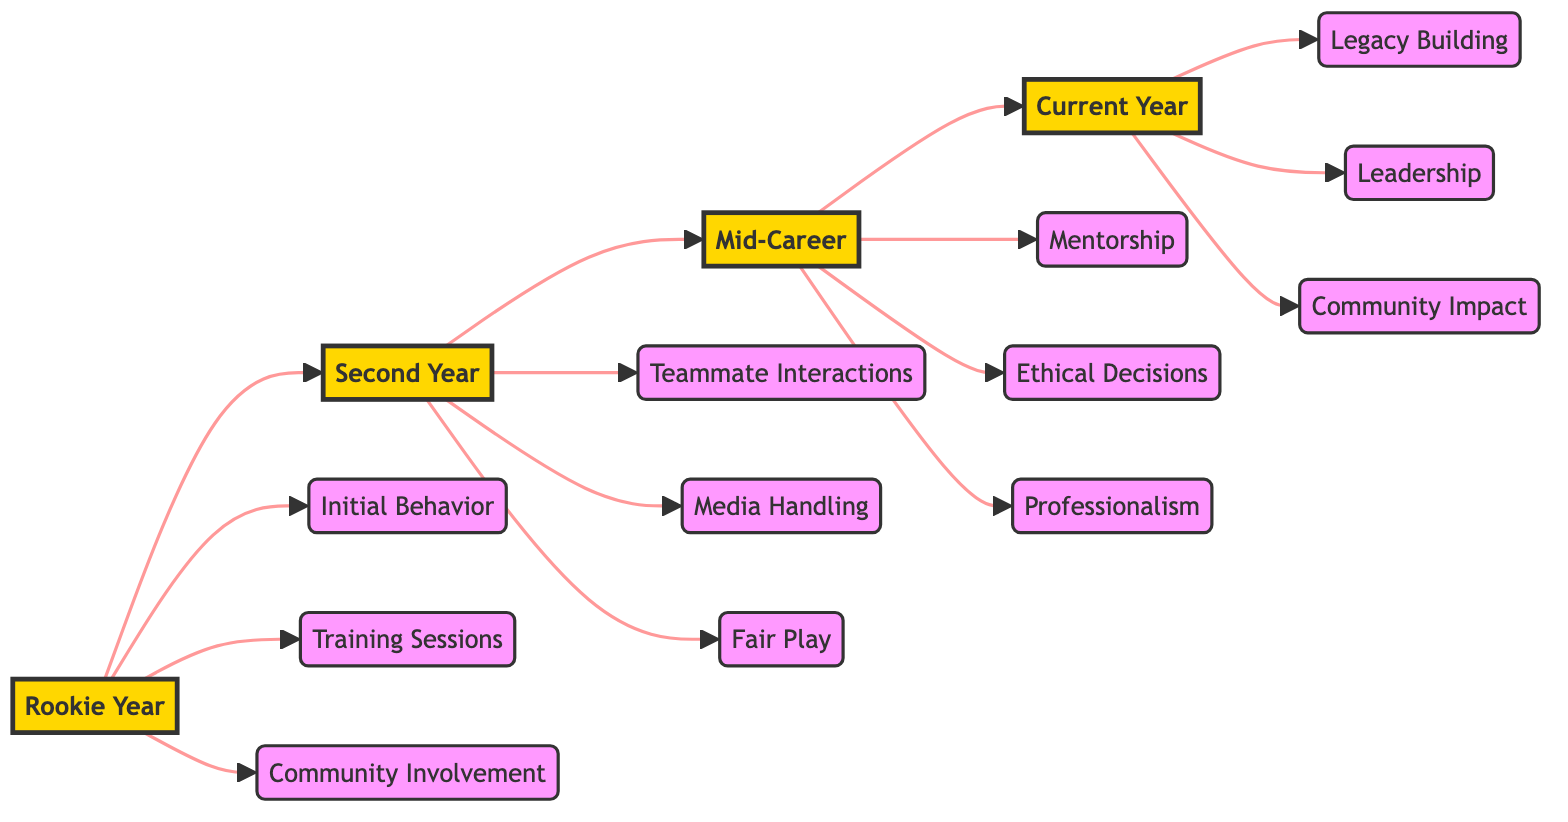What are the three aspects focused on in the Rookie Year? According to the diagram, the Rookie Year focuses on three aspects: Initial Behavior, Training Sessions, and Community Involvement.
Answer: Initial Behavior, Training Sessions, Community Involvement How many stages are depicted in the flowchart? The diagram displays four stages: Rookie Year, Second Year, Mid-Career, and Current Year. Counting each distinct stage gives a total of four stages.
Answer: 4 Which aspect corresponds to the Mid-Career stage? The Mid-Career stage includes three aspects: Mentorship, Ethical Decisions, and Professionalism. Any aspect from this list will suffice as an answer.
Answer: Mentorship, Ethical Decisions, Professionalism What connects the Rookie Year to the Current Year? The flowchart indicates a direct progression from Rookie Year to Second Year, then to Mid-Career, and finally to Current Year, establishing a linear connection from the start to the latest stage of development.
Answer: Progression through stages What is highlighted as a significant contribution in the Current Year? In the Current Year stage, Community Impact is highlighted as having significant contributions outside of sports, which emphasizes the athlete's role in their community.
Answer: Community Impact How does the Second Year differ from the Rookie Year? The Second Year emphasizes aspects such as Teammate Interactions, Media Handling, and Fair Play, which differ from the Rookie Year's focus on Initial Behavior, Training Sessions, and Community Involvement, showcasing the athlete's growth in social and competitive scenarios.
Answer: Emphasis on teamwork and media Which aspect shows the athlete's development in leadership? Leadership is specifically noted as an aspect in the Current Year, indicating the athlete's evolved role and influence within their team and community.
Answer: Leadership How many aspects are present in the diagram for each stage? Each stage has three distinct aspects, showcasing specific areas of focus for the athlete's development throughout their career as shown in the flowchart.
Answer: 3 